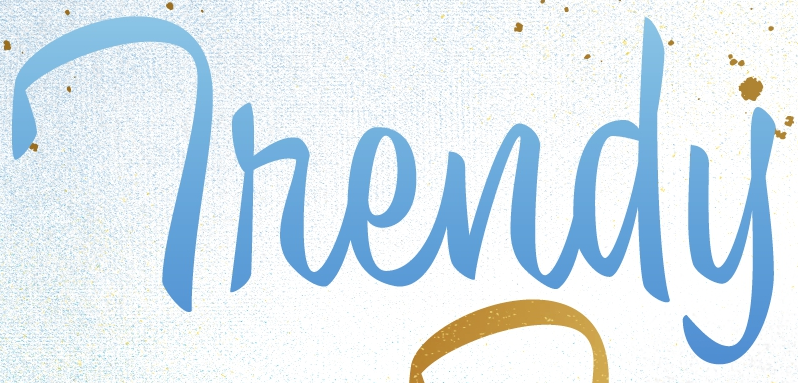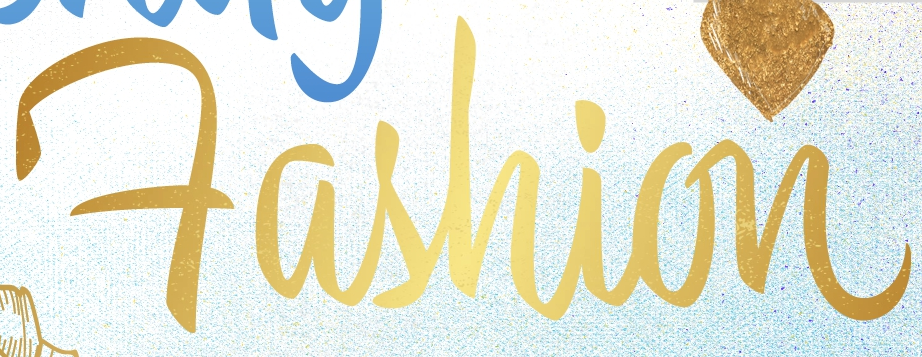Transcribe the words shown in these images in order, separated by a semicolon. Thendy; Fashion 